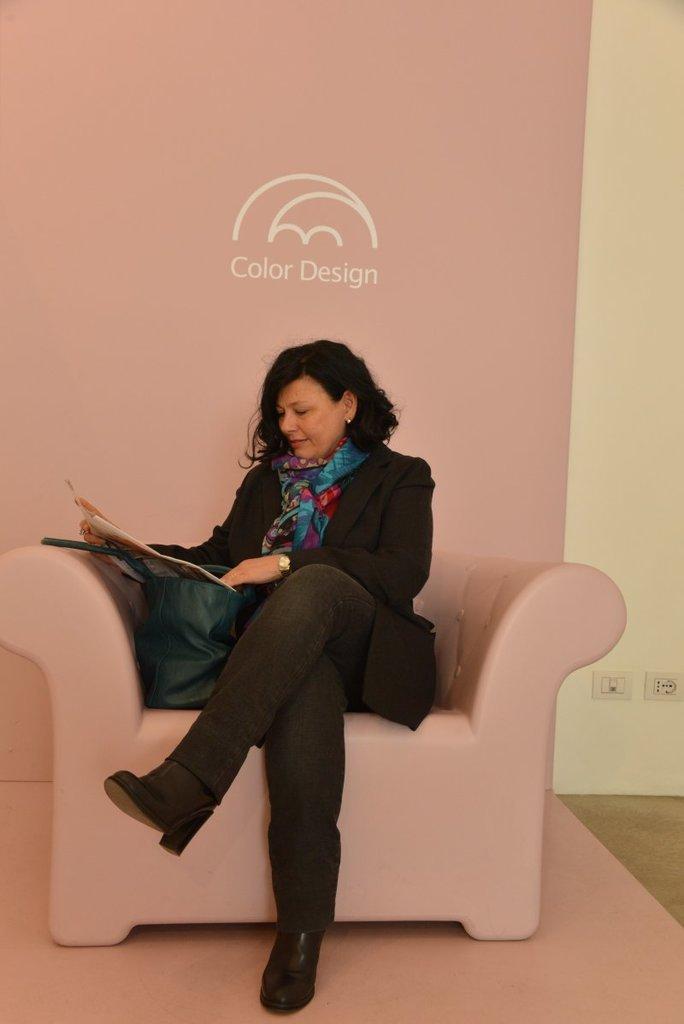Could you give a brief overview of what you see in this image? In this picture there is a woman sitting on the couch, she is reading a book and smiling 